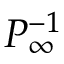<formula> <loc_0><loc_0><loc_500><loc_500>P _ { \infty } ^ { - 1 }</formula> 